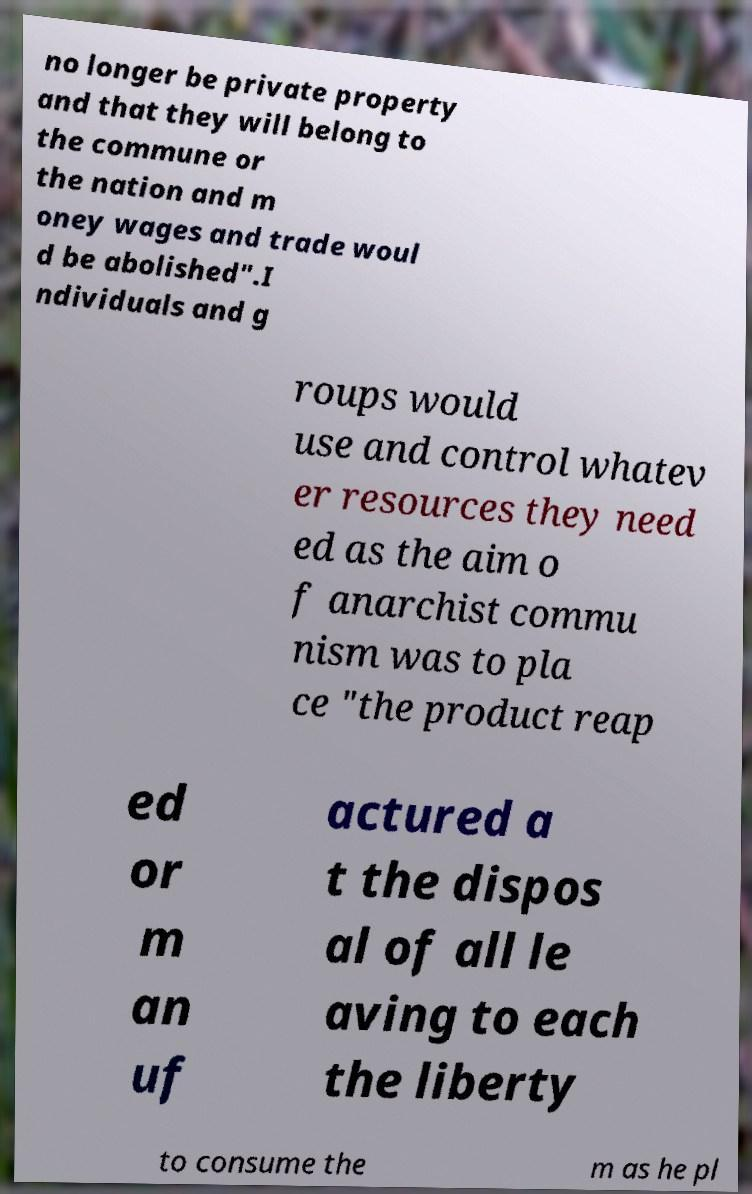Please read and relay the text visible in this image. What does it say? no longer be private property and that they will belong to the commune or the nation and m oney wages and trade woul d be abolished".I ndividuals and g roups would use and control whatev er resources they need ed as the aim o f anarchist commu nism was to pla ce "the product reap ed or m an uf actured a t the dispos al of all le aving to each the liberty to consume the m as he pl 